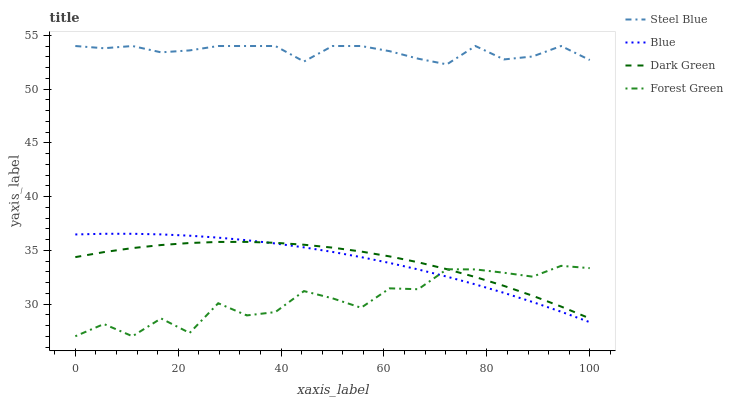Does Forest Green have the minimum area under the curve?
Answer yes or no. Yes. Does Steel Blue have the maximum area under the curve?
Answer yes or no. Yes. Does Steel Blue have the minimum area under the curve?
Answer yes or no. No. Does Forest Green have the maximum area under the curve?
Answer yes or no. No. Is Blue the smoothest?
Answer yes or no. Yes. Is Forest Green the roughest?
Answer yes or no. Yes. Is Steel Blue the smoothest?
Answer yes or no. No. Is Steel Blue the roughest?
Answer yes or no. No. Does Forest Green have the lowest value?
Answer yes or no. Yes. Does Steel Blue have the lowest value?
Answer yes or no. No. Does Steel Blue have the highest value?
Answer yes or no. Yes. Does Forest Green have the highest value?
Answer yes or no. No. Is Blue less than Steel Blue?
Answer yes or no. Yes. Is Steel Blue greater than Forest Green?
Answer yes or no. Yes. Does Forest Green intersect Blue?
Answer yes or no. Yes. Is Forest Green less than Blue?
Answer yes or no. No. Is Forest Green greater than Blue?
Answer yes or no. No. Does Blue intersect Steel Blue?
Answer yes or no. No. 